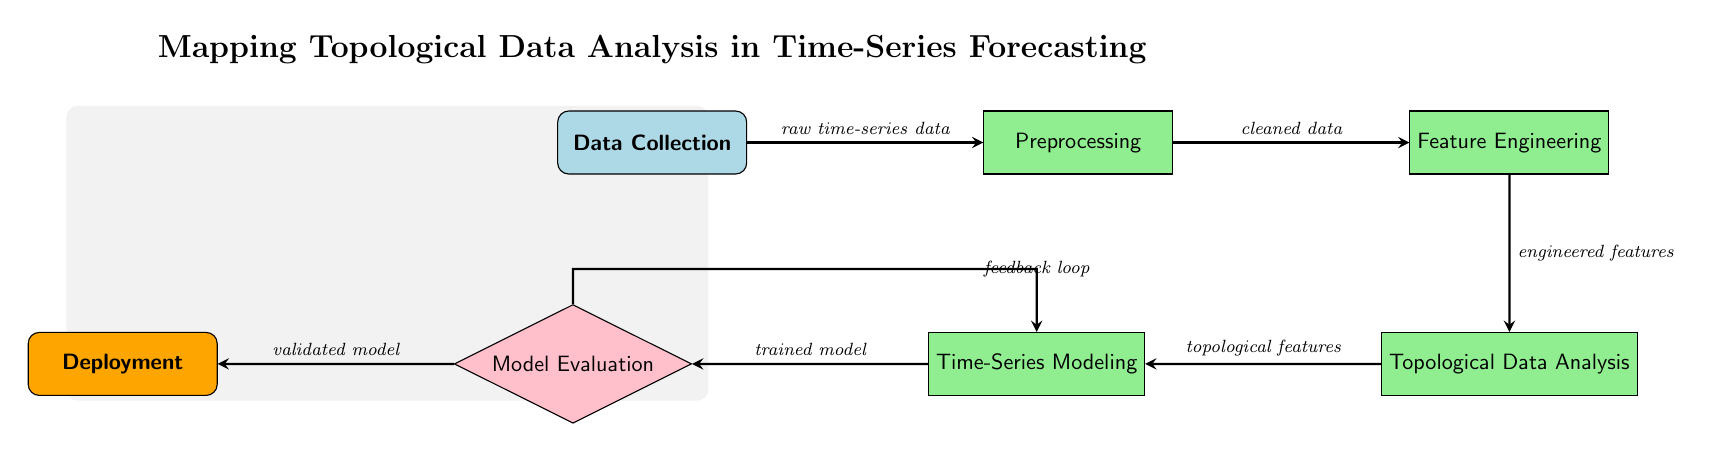What is the first step in the workflow? The first step in the workflow is indicated at the top of the diagram and labeled as "Data Collection."
Answer: Data Collection What type of node is "Model Evaluation"? "Model Evaluation" is depicted as a diamond-shaped node, which indicates it is a decision point within the workflow.
Answer: Decision How many processes are there in the diagram? The processes in the diagram include three rectangular nodes: "Preprocessing," "Feature Engineering," and "Topological Data Analysis." Thus, the count is three.
Answer: Three What type of output is produced after "Model Evaluation"? The output produced after "Model Evaluation" is labeled as "Deployment," which is also a rectangular node, indicating it is the final output step.
Answer: Deployment What relationship exists between "Feature Engineering" and "Topological Data Analysis"? "Feature Engineering" directly leads to "Topological Data Analysis," as indicated by the flow arrow that points from "Feature Engineering" to "Topological Data Analysis."
Answer: Direct What is used as input for the "Preprocessing" step? The input for the "Preprocessing" step is "raw time-series data," which is specified in the flow arrow coming into the "Preprocessing" node.
Answer: Raw time-series data How does "Model Evaluation" relate to "Time-Series Modeling"? "Model Evaluation" follows "Time-Series Modeling" directly in the flow, indicating it occurs after the model is trained in the "Time-Series Modeling" step.
Answer: Directly follows What feature emerges from "Topological Data Analysis"? The output that emerges from "Topological Data Analysis" is labeled as "topological features," demonstrating the transformation of data at this step.
Answer: Topological features What indicates the feedback loop in the diagram? The feedback loop is indicated by a curved arrow that points back from "Model Evaluation" to "Time-Series Modeling," marking the iterative nature of the process.
Answer: Feedback loop 